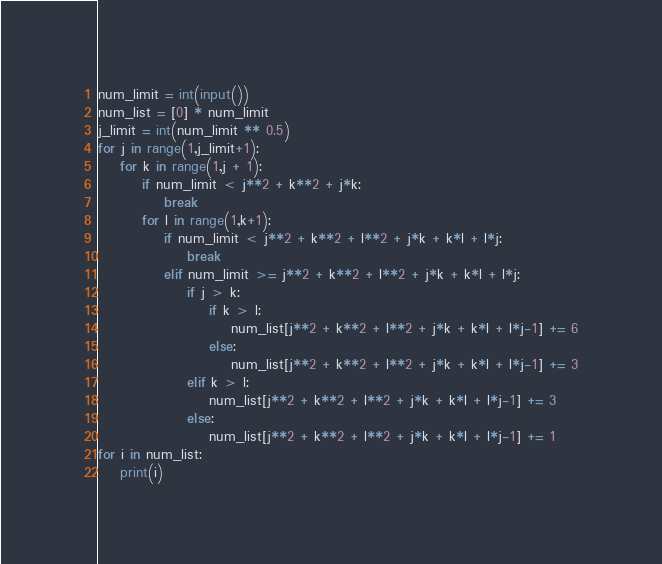Convert code to text. <code><loc_0><loc_0><loc_500><loc_500><_Python_>num_limit = int(input())
num_list = [0] * num_limit
j_limit = int(num_limit ** 0.5)
for j in range(1,j_limit+1):
    for k in range(1,j + 1):
        if num_limit < j**2 + k**2 + j*k:
            break
        for l in range(1,k+1):
            if num_limit < j**2 + k**2 + l**2 + j*k + k*l + l*j:
                break
            elif num_limit >= j**2 + k**2 + l**2 + j*k + k*l + l*j:
                if j > k:
                    if k > l:
                        num_list[j**2 + k**2 + l**2 + j*k + k*l + l*j-1] += 6
                    else:
                        num_list[j**2 + k**2 + l**2 + j*k + k*l + l*j-1] += 3
                elif k > l:
                    num_list[j**2 + k**2 + l**2 + j*k + k*l + l*j-1] += 3
                else:
                    num_list[j**2 + k**2 + l**2 + j*k + k*l + l*j-1] += 1
for i in num_list:
    print(i)</code> 